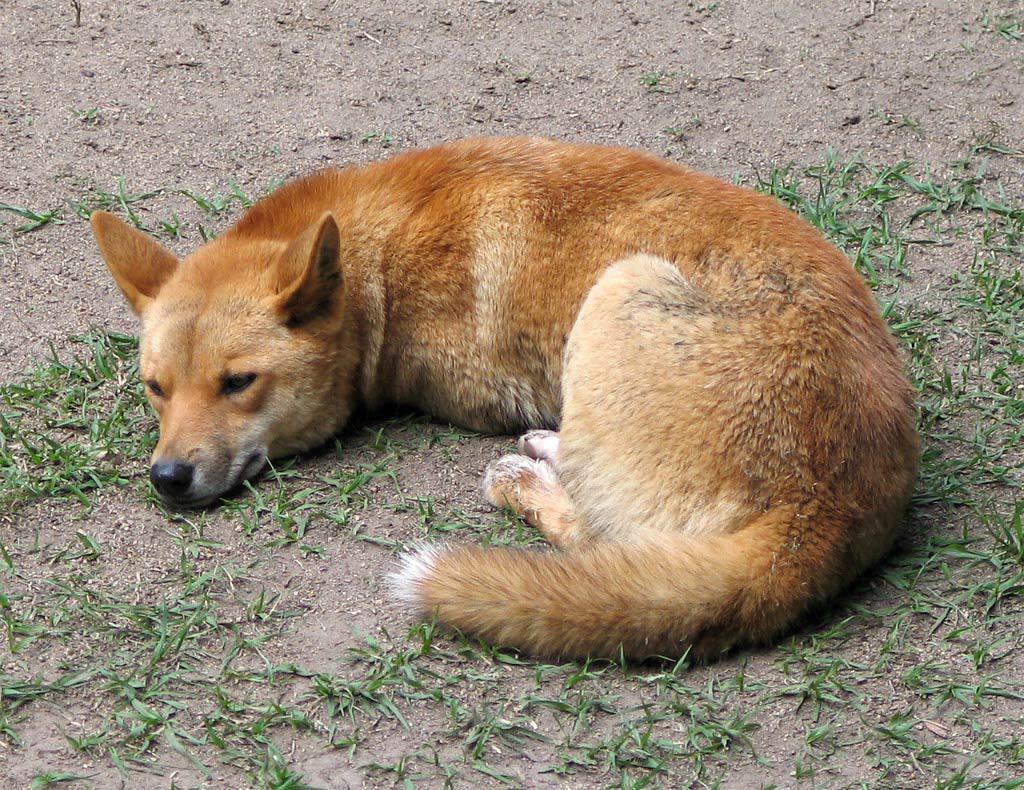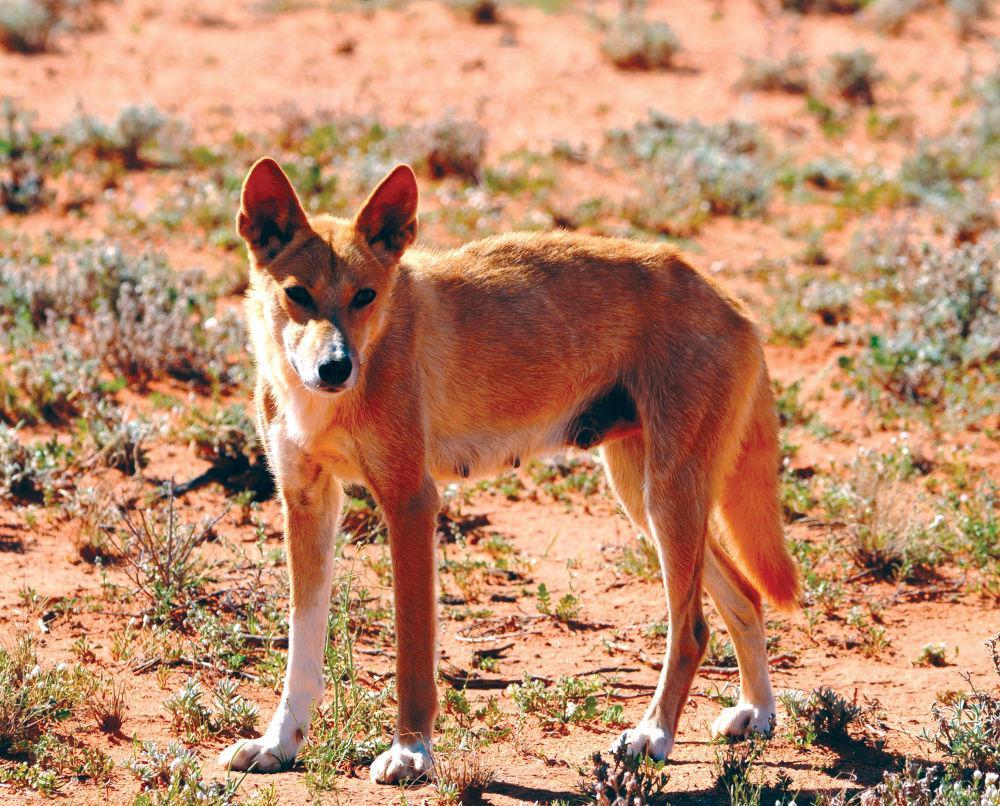The first image is the image on the left, the second image is the image on the right. Analyze the images presented: Is the assertion "There is an animal lying down in one of the images" valid? Answer yes or no. Yes. The first image is the image on the left, the second image is the image on the right. For the images shown, is this caption "A canine is on the ground in a resting pose, in one image." true? Answer yes or no. Yes. The first image is the image on the left, the second image is the image on the right. Examine the images to the left and right. Is the description "the animal in the image on the left is lying down" accurate? Answer yes or no. Yes. The first image is the image on the left, the second image is the image on the right. Analyze the images presented: Is the assertion "1 dingo is standing on all fours." valid? Answer yes or no. Yes. 